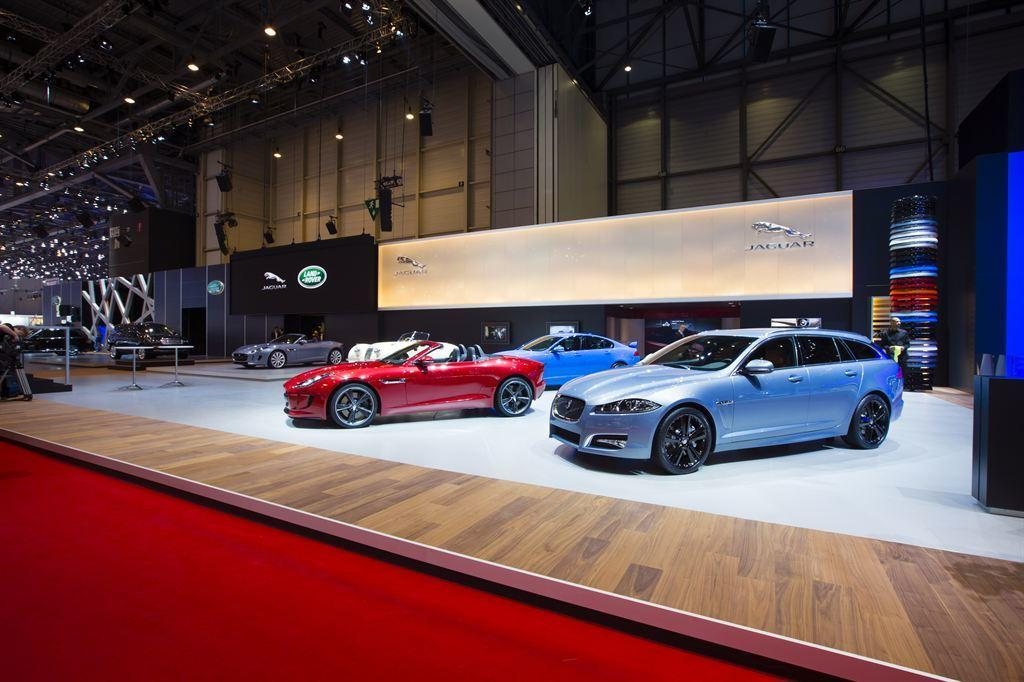What type of objects are on the floor in the image? There are vehicles on the floor in the image. What else can be seen on the floor besides the vehicles? There are other objects on the floor in the image. What is present on the boards in the image? There are boards with logos in the image. What type of furniture is in the image? There are tables in the image. What can be seen on the ceiling in the image? There are lights on the ceiling in the image. What type of care is being provided to the bottle in the image? There is no bottle present in the image, so no care is being provided. What is the person in the image reading? There is no person or reading material present in the image. 